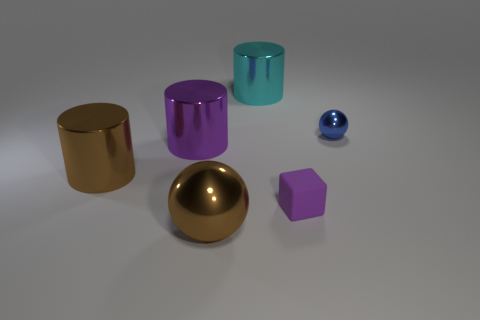Subtract all brown cubes. Subtract all gray spheres. How many cubes are left? 1 Add 4 big brown matte cubes. How many objects exist? 10 Subtract all balls. How many objects are left? 4 Add 5 gray rubber cylinders. How many gray rubber cylinders exist? 5 Subtract 1 blue spheres. How many objects are left? 5 Subtract all cyan shiny cylinders. Subtract all small rubber blocks. How many objects are left? 4 Add 6 tiny shiny spheres. How many tiny shiny spheres are left? 7 